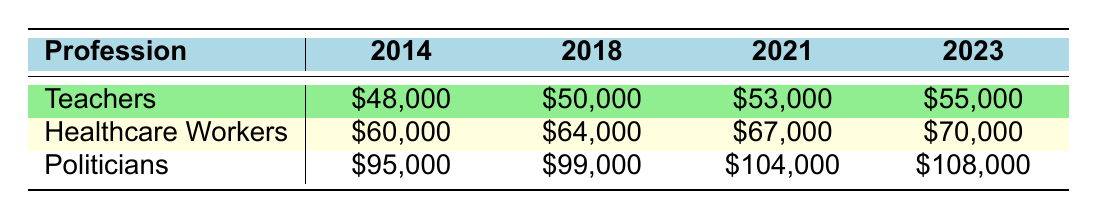What was the average salary for teachers in 2021? The table shows that the average salary for teachers in 2021 was \$53,000.
Answer: \$53,000 How much did the average salary for healthcare workers increase from 2018 to 2023? The average salary for healthcare workers in 2018 was \$64,000 and in 2023 it is \$70,000. The increase is \$70,000 - \$64,000 = \$6,000.
Answer: \$6,000 Did the salary for politicians increase every year from 2014 to 2023? Yes, the table shows that the salary for politicians increased each year from \$95,000 in 2014 to \$108,000 in 2023 without any decrease.
Answer: Yes What was the difference in average salaries between politicians and teachers in 2014? In 2014, the average salary for politicians was \$95,000, and for teachers, it was \$48,000. The difference is \$95,000 - \$48,000 = \$47,000.
Answer: \$47,000 What was the average salary for healthcare workers in 2014? According to the table, healthcare workers earned an average salary of \$60,000 in 2014.
Answer: \$60,000 Which profession had the highest average salary in 2021? In 2021, the average salaries were \$53,000 for teachers, \$67,000 for healthcare workers, and \$104,000 for politicians. Politicians had the highest average salary.
Answer: Politicians What is the average salary for teachers over the last decade? To calculate, we take the total of teachers' salaries from 2014 to 2023: \$48,000 + \$49,500 + \$49,000 + \$50,000 + \$51,000 + \$52,000 + \$53,000 + \$55,000 = \$91,000. Then, we divide by 10 years. The average is \$91,000 / 10 = \$51,000.
Answer: \$51,000 How much more do politicians earn than healthcare workers on average in 2023? In 2023, the average salary for politicians is \$108,000 and for healthcare workers, it's \$70,000. The difference is \$108,000 - \$70,000 = \$38,000.
Answer: \$38,000 How much did each profession's salary increase from 2014 to 2023? Teachers increased from \$48,000 to \$55,000, a rise of \$7,000; healthcare workers from \$60,000 to \$70,000, an increase of \$10,000; and politicians from \$95,000 to \$108,000, a rise of \$13,000.
Answer: Teachers: \$7,000, Healthcare Workers: \$10,000, Politicians: \$13,000 In which year did healthcare workers have a salary of \$64000? The table indicates that healthcare workers had a salary of \$64,000 in 2018.
Answer: 2018 